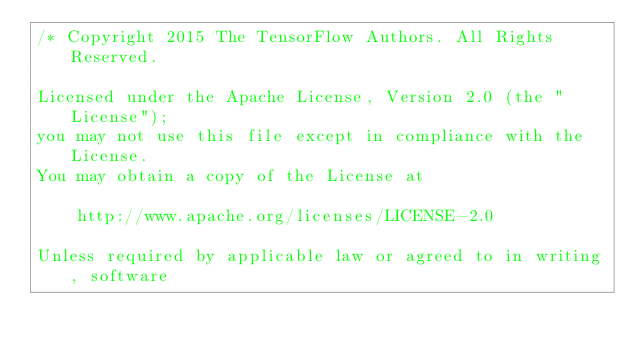<code> <loc_0><loc_0><loc_500><loc_500><_C++_>/* Copyright 2015 The TensorFlow Authors. All Rights Reserved.

Licensed under the Apache License, Version 2.0 (the "License");
you may not use this file except in compliance with the License.
You may obtain a copy of the License at

    http://www.apache.org/licenses/LICENSE-2.0

Unless required by applicable law or agreed to in writing, software</code> 